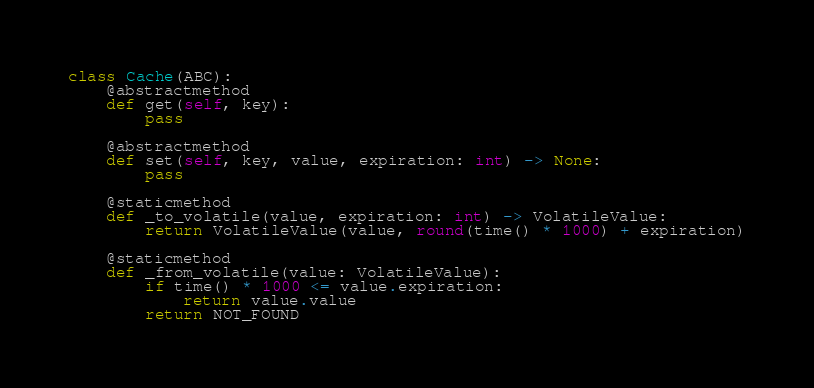Convert code to text. <code><loc_0><loc_0><loc_500><loc_500><_Python_>

class Cache(ABC):
    @abstractmethod
    def get(self, key):
        pass

    @abstractmethod
    def set(self, key, value, expiration: int) -> None:
        pass

    @staticmethod
    def _to_volatile(value, expiration: int) -> VolatileValue:
        return VolatileValue(value, round(time() * 1000) + expiration)

    @staticmethod
    def _from_volatile(value: VolatileValue):
        if time() * 1000 <= value.expiration:
            return value.value
        return NOT_FOUND
</code> 